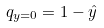<formula> <loc_0><loc_0><loc_500><loc_500>q _ { y = 0 } = 1 - \hat { y }</formula> 